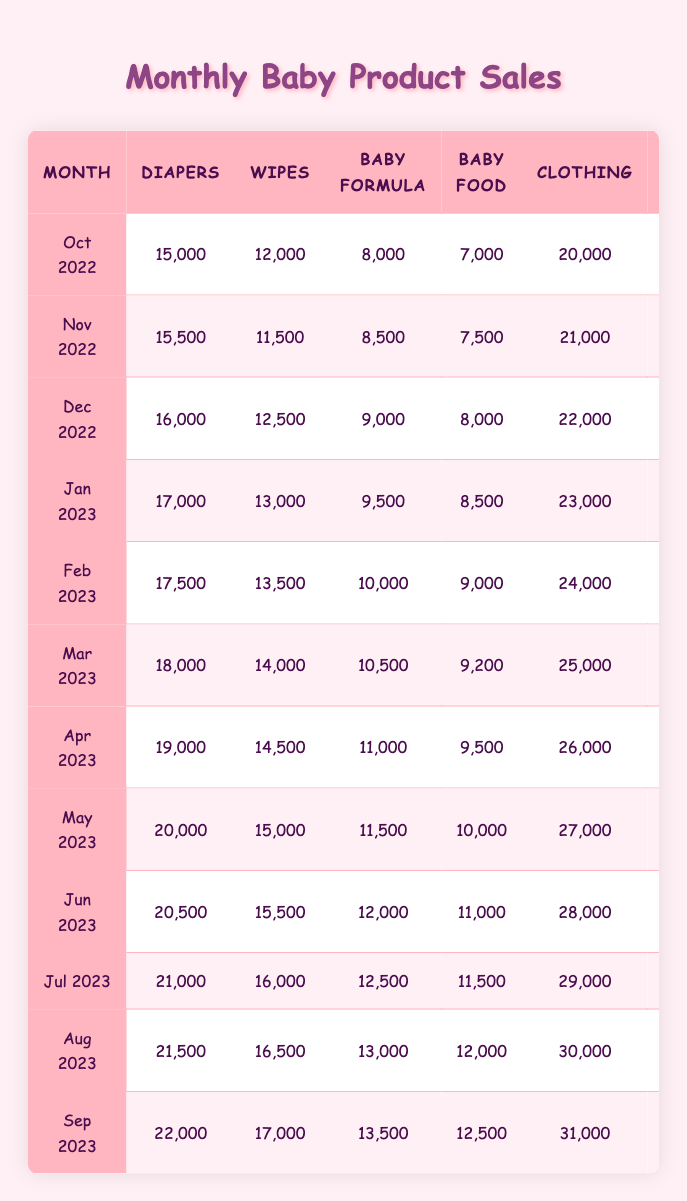What was the total number of diapers sold in September 2023? In September 2023, the table shows that 22,000 diapers were sold. This is a specific retrieval question that can be answered directly by looking at the table.
Answer: 22,000 What category had the highest sales in May 2023? In May 2023, looking at the table, clothing had the highest sales with 27,000 units sold, which is more than any other category for that month.
Answer: Clothing What is the average number of car seats sold over the last year? To find the average, we add the car seats sold from each month (3,000 + 3,200 + 3,400 + 3,800 + 3,600 + 3,700 + 3,900 + 4,000 + 4,100 + 4,200 + 4,300 + 4,400 =  46,900) and divide by 12 (as there are 12 months), resulting in approximately 3,908.33.
Answer: 3,908 Were more wipes sold in March 2023 than in April 2023? In March 2023, 14,000 wipes were sold, while in April 2023, 14,500 were sold. Since 14,500 is greater than 14,000, the statement is false.
Answer: No What was the increase in baby food sales from October 2022 to September 2023? In October 2022, 7,000 units of baby food were sold, and in September 2023, 12,500 units were sold. To find the increase, we subtract: 12,500 - 7,000 = 5,500.
Answer: 5,500 Which month experienced the highest sales for strollers? Looking through the table, the highest sales for strollers occurred in August 2023, where 6,500 units were sold, which is the maximum recorded across all months.
Answer: August 2023 How many more toys were sold in September 2023 compared to January 2023? In September 2023, 16,500 toys were sold, while in January 2023, 11,000 toys were sold. The difference can be found by subtracting: 16,500 - 11,000 = 5,500.
Answer: 5,500 Is the total number of diapers sold in 2023 greater than that in 2022? To determine this, we first calculate the total for 2022 (15,000 + 15,500 + 16,000 + 17,000 + 17,500 + 18,000 + 19,000 + 20,000 + 20,500 + 21,000 + 21,500 + 22,000 = 239,500) and for 2023 (17,000 + 17,500 + 18,000 + 19,000 + 20,000 + 20,500 + 21,000 + 21,500 + 22,000 = 235,500). Since 239,500 > 235,500, the statement is true.
Answer: Yes What percentage increase in clothing sales was observed from October 2022 to September 2023? In October 2022, clothing sales were 20,000, and in September 2023, they were 31,000. The increase is 31,000 - 20,000 = 11,000. To find the percentage increase: (11,000 / 20,000) * 100 = 55%.
Answer: 55% Which month had the lowest sales for car seats and how many were sold? The lowest sales for car seats were in October 2022, where only 3,000 units were sold. This is a straightforward retrieval from the table.
Answer: 3,000 Was the total sale of baby formula in the first quarter of 2023 greater than in the last quarter of 2022? For the first quarter of 2023, baby formula sales were 9,500 (January) + 10,000 (February) + 10,500 (March) = 30,000. In the last quarter of 2022, total sales were 8,500 (November) + 9,000 (December) = 17,500. Since 30,000 > 17,500, the statement is true.
Answer: Yes 